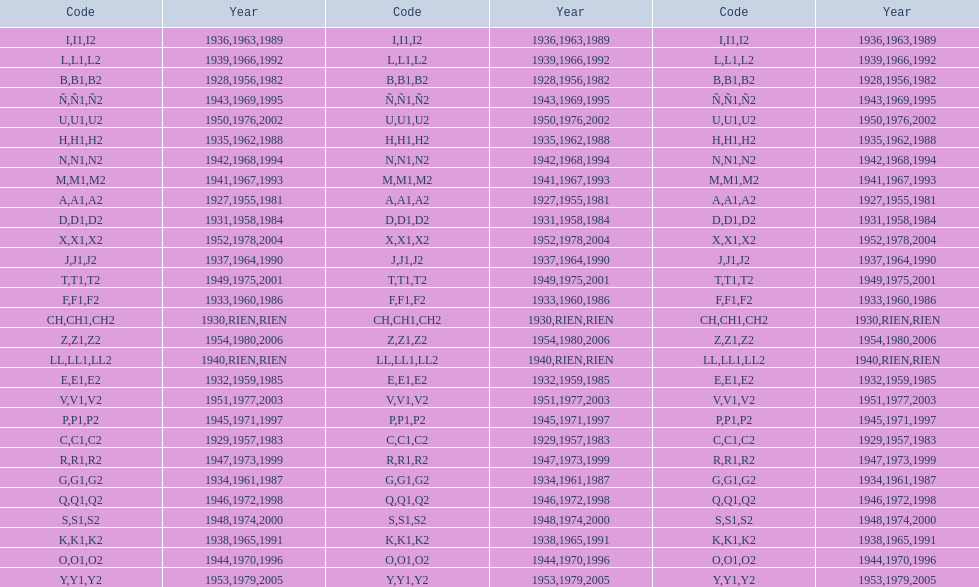Number of codes containing a 2? 28. 